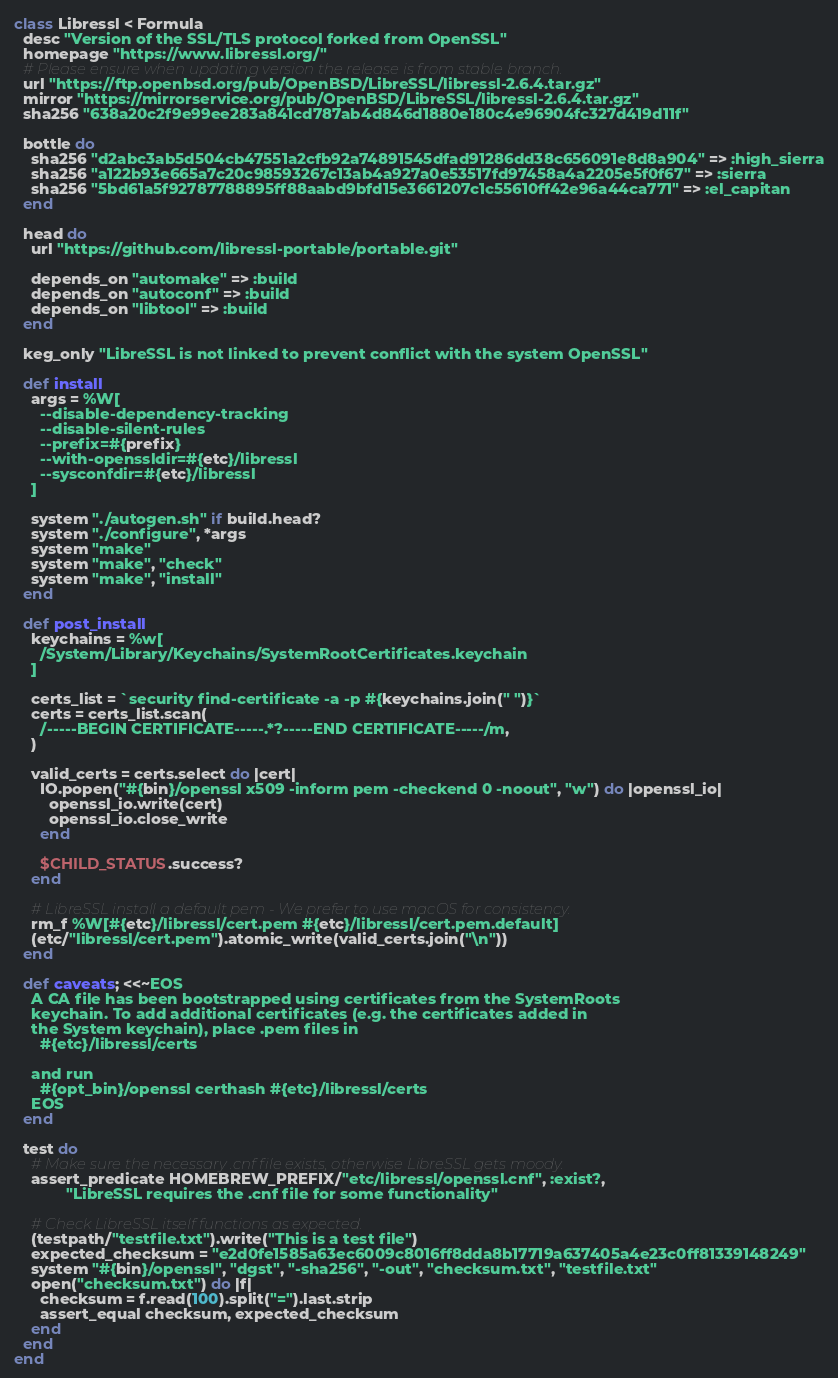Convert code to text. <code><loc_0><loc_0><loc_500><loc_500><_Ruby_>class Libressl < Formula
  desc "Version of the SSL/TLS protocol forked from OpenSSL"
  homepage "https://www.libressl.org/"
  # Please ensure when updating version the release is from stable branch.
  url "https://ftp.openbsd.org/pub/OpenBSD/LibreSSL/libressl-2.6.4.tar.gz"
  mirror "https://mirrorservice.org/pub/OpenBSD/LibreSSL/libressl-2.6.4.tar.gz"
  sha256 "638a20c2f9e99ee283a841cd787ab4d846d1880e180c4e96904fc327d419d11f"

  bottle do
    sha256 "d2abc3ab5d504cb47551a2cfb92a74891545dfad91286dd38c656091e8d8a904" => :high_sierra
    sha256 "a122b93e665a7c20c98593267c13ab4a927a0e53517fd97458a4a2205e5f0f67" => :sierra
    sha256 "5bd61a5f92787788895ff88aabd9bfd15e3661207c1c55610ff42e96a44ca771" => :el_capitan
  end

  head do
    url "https://github.com/libressl-portable/portable.git"

    depends_on "automake" => :build
    depends_on "autoconf" => :build
    depends_on "libtool" => :build
  end

  keg_only "LibreSSL is not linked to prevent conflict with the system OpenSSL"

  def install
    args = %W[
      --disable-dependency-tracking
      --disable-silent-rules
      --prefix=#{prefix}
      --with-openssldir=#{etc}/libressl
      --sysconfdir=#{etc}/libressl
    ]

    system "./autogen.sh" if build.head?
    system "./configure", *args
    system "make"
    system "make", "check"
    system "make", "install"
  end

  def post_install
    keychains = %w[
      /System/Library/Keychains/SystemRootCertificates.keychain
    ]

    certs_list = `security find-certificate -a -p #{keychains.join(" ")}`
    certs = certs_list.scan(
      /-----BEGIN CERTIFICATE-----.*?-----END CERTIFICATE-----/m,
    )

    valid_certs = certs.select do |cert|
      IO.popen("#{bin}/openssl x509 -inform pem -checkend 0 -noout", "w") do |openssl_io|
        openssl_io.write(cert)
        openssl_io.close_write
      end

      $CHILD_STATUS.success?
    end

    # LibreSSL install a default pem - We prefer to use macOS for consistency.
    rm_f %W[#{etc}/libressl/cert.pem #{etc}/libressl/cert.pem.default]
    (etc/"libressl/cert.pem").atomic_write(valid_certs.join("\n"))
  end

  def caveats; <<~EOS
    A CA file has been bootstrapped using certificates from the SystemRoots
    keychain. To add additional certificates (e.g. the certificates added in
    the System keychain), place .pem files in
      #{etc}/libressl/certs

    and run
      #{opt_bin}/openssl certhash #{etc}/libressl/certs
    EOS
  end

  test do
    # Make sure the necessary .cnf file exists, otherwise LibreSSL gets moody.
    assert_predicate HOMEBREW_PREFIX/"etc/libressl/openssl.cnf", :exist?,
            "LibreSSL requires the .cnf file for some functionality"

    # Check LibreSSL itself functions as expected.
    (testpath/"testfile.txt").write("This is a test file")
    expected_checksum = "e2d0fe1585a63ec6009c8016ff8dda8b17719a637405a4e23c0ff81339148249"
    system "#{bin}/openssl", "dgst", "-sha256", "-out", "checksum.txt", "testfile.txt"
    open("checksum.txt") do |f|
      checksum = f.read(100).split("=").last.strip
      assert_equal checksum, expected_checksum
    end
  end
end
</code> 